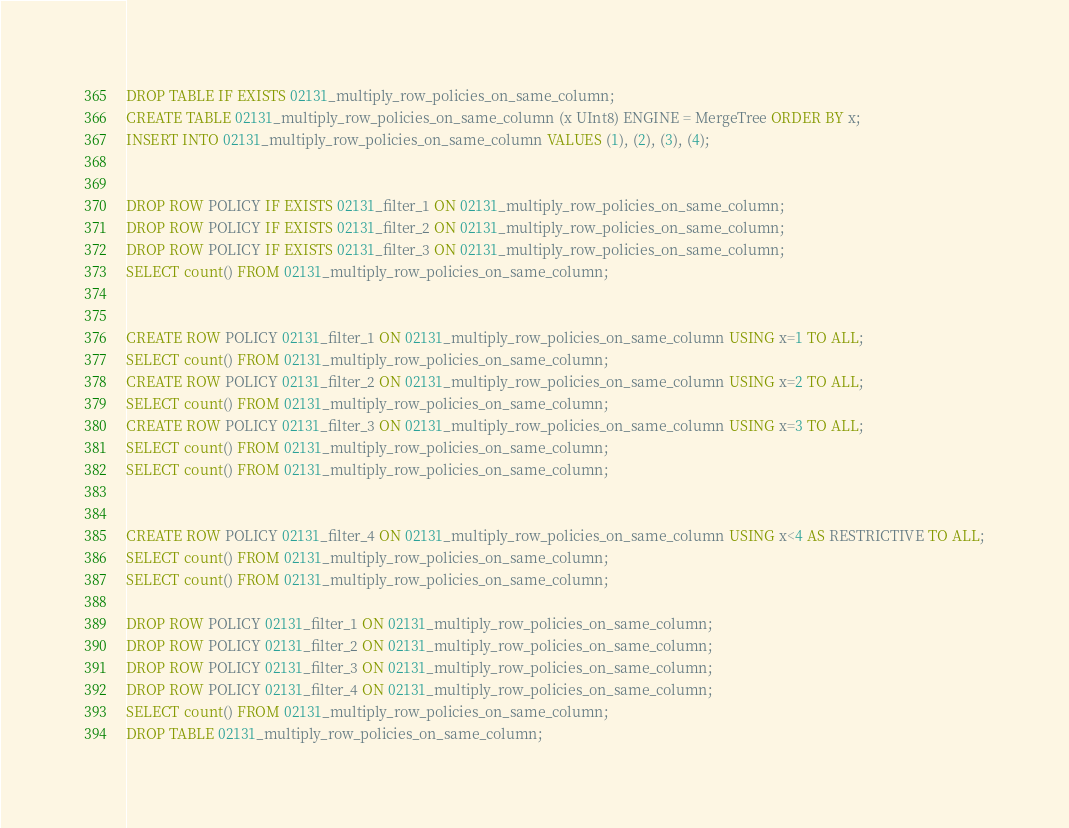<code> <loc_0><loc_0><loc_500><loc_500><_SQL_>DROP TABLE IF EXISTS 02131_multiply_row_policies_on_same_column;
CREATE TABLE 02131_multiply_row_policies_on_same_column (x UInt8) ENGINE = MergeTree ORDER BY x;
INSERT INTO 02131_multiply_row_policies_on_same_column VALUES (1), (2), (3), (4);


DROP ROW POLICY IF EXISTS 02131_filter_1 ON 02131_multiply_row_policies_on_same_column;
DROP ROW POLICY IF EXISTS 02131_filter_2 ON 02131_multiply_row_policies_on_same_column;
DROP ROW POLICY IF EXISTS 02131_filter_3 ON 02131_multiply_row_policies_on_same_column;
SELECT count() FROM 02131_multiply_row_policies_on_same_column;


CREATE ROW POLICY 02131_filter_1 ON 02131_multiply_row_policies_on_same_column USING x=1 TO ALL;
SELECT count() FROM 02131_multiply_row_policies_on_same_column;
CREATE ROW POLICY 02131_filter_2 ON 02131_multiply_row_policies_on_same_column USING x=2 TO ALL;
SELECT count() FROM 02131_multiply_row_policies_on_same_column;
CREATE ROW POLICY 02131_filter_3 ON 02131_multiply_row_policies_on_same_column USING x=3 TO ALL;
SELECT count() FROM 02131_multiply_row_policies_on_same_column;
SELECT count() FROM 02131_multiply_row_policies_on_same_column;


CREATE ROW POLICY 02131_filter_4 ON 02131_multiply_row_policies_on_same_column USING x<4 AS RESTRICTIVE TO ALL;
SELECT count() FROM 02131_multiply_row_policies_on_same_column;
SELECT count() FROM 02131_multiply_row_policies_on_same_column;

DROP ROW POLICY 02131_filter_1 ON 02131_multiply_row_policies_on_same_column;
DROP ROW POLICY 02131_filter_2 ON 02131_multiply_row_policies_on_same_column;
DROP ROW POLICY 02131_filter_3 ON 02131_multiply_row_policies_on_same_column;
DROP ROW POLICY 02131_filter_4 ON 02131_multiply_row_policies_on_same_column;
SELECT count() FROM 02131_multiply_row_policies_on_same_column;
DROP TABLE 02131_multiply_row_policies_on_same_column;
</code> 